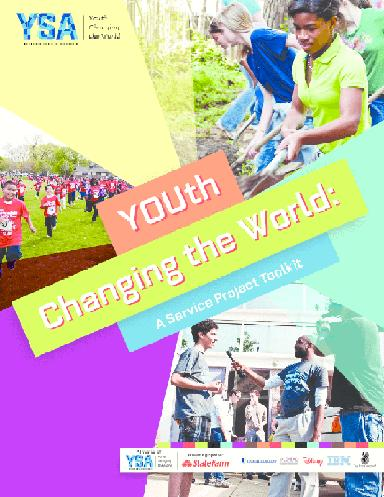How can youths get involved with YSA? Youths can get involved with Youth Service America (YSA) by visiting the YSA website to find a variety of service project ideas, grants, and resources aimed at supporting their involvement in community service and social change initiatives. Additionally, they can join campaigns like Global Youth Service Day, partake in leadership development programs, or even start their own projects using YSA's toolkit for guidance. 